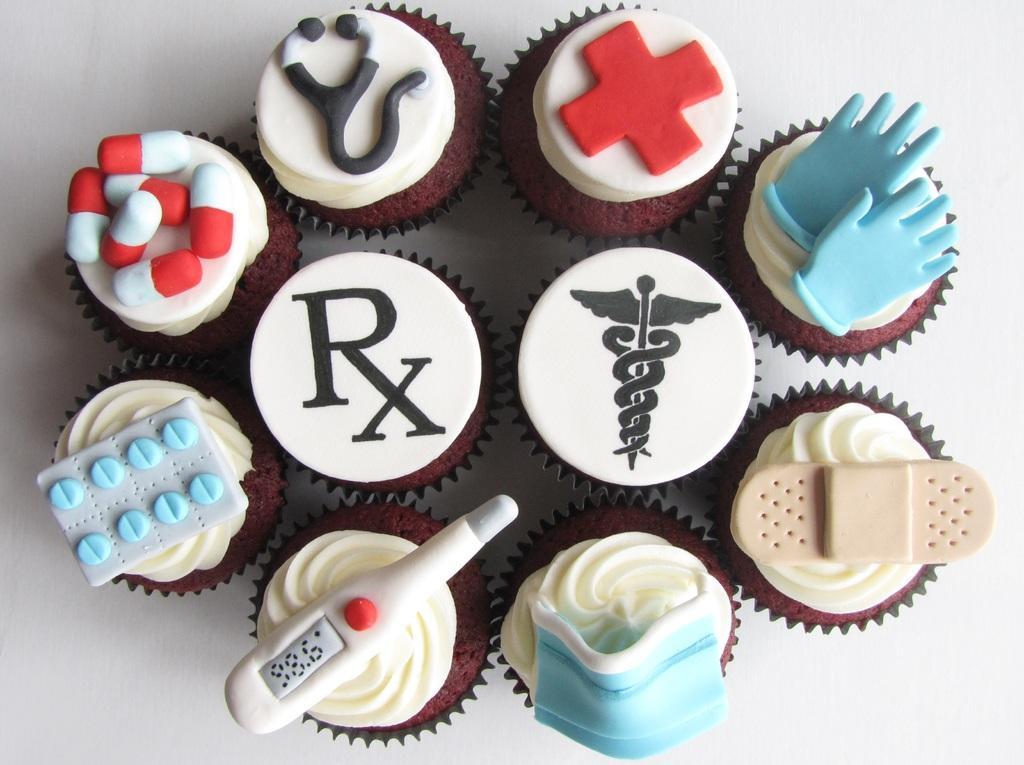In one or two sentences, can you explain what this image depicts? In the image we can see there are many cupcakes and this is a white surface. On the cupcake we can see the glove, plus symbol, stethoscope, tablets, logo, bandage, face mask and a thermometer. 